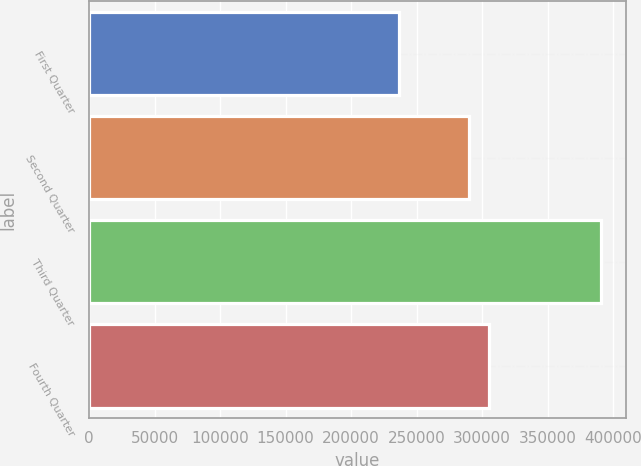<chart> <loc_0><loc_0><loc_500><loc_500><bar_chart><fcel>First Quarter<fcel>Second Quarter<fcel>Third Quarter<fcel>Fourth Quarter<nl><fcel>236829<fcel>289573<fcel>390337<fcel>304924<nl></chart> 